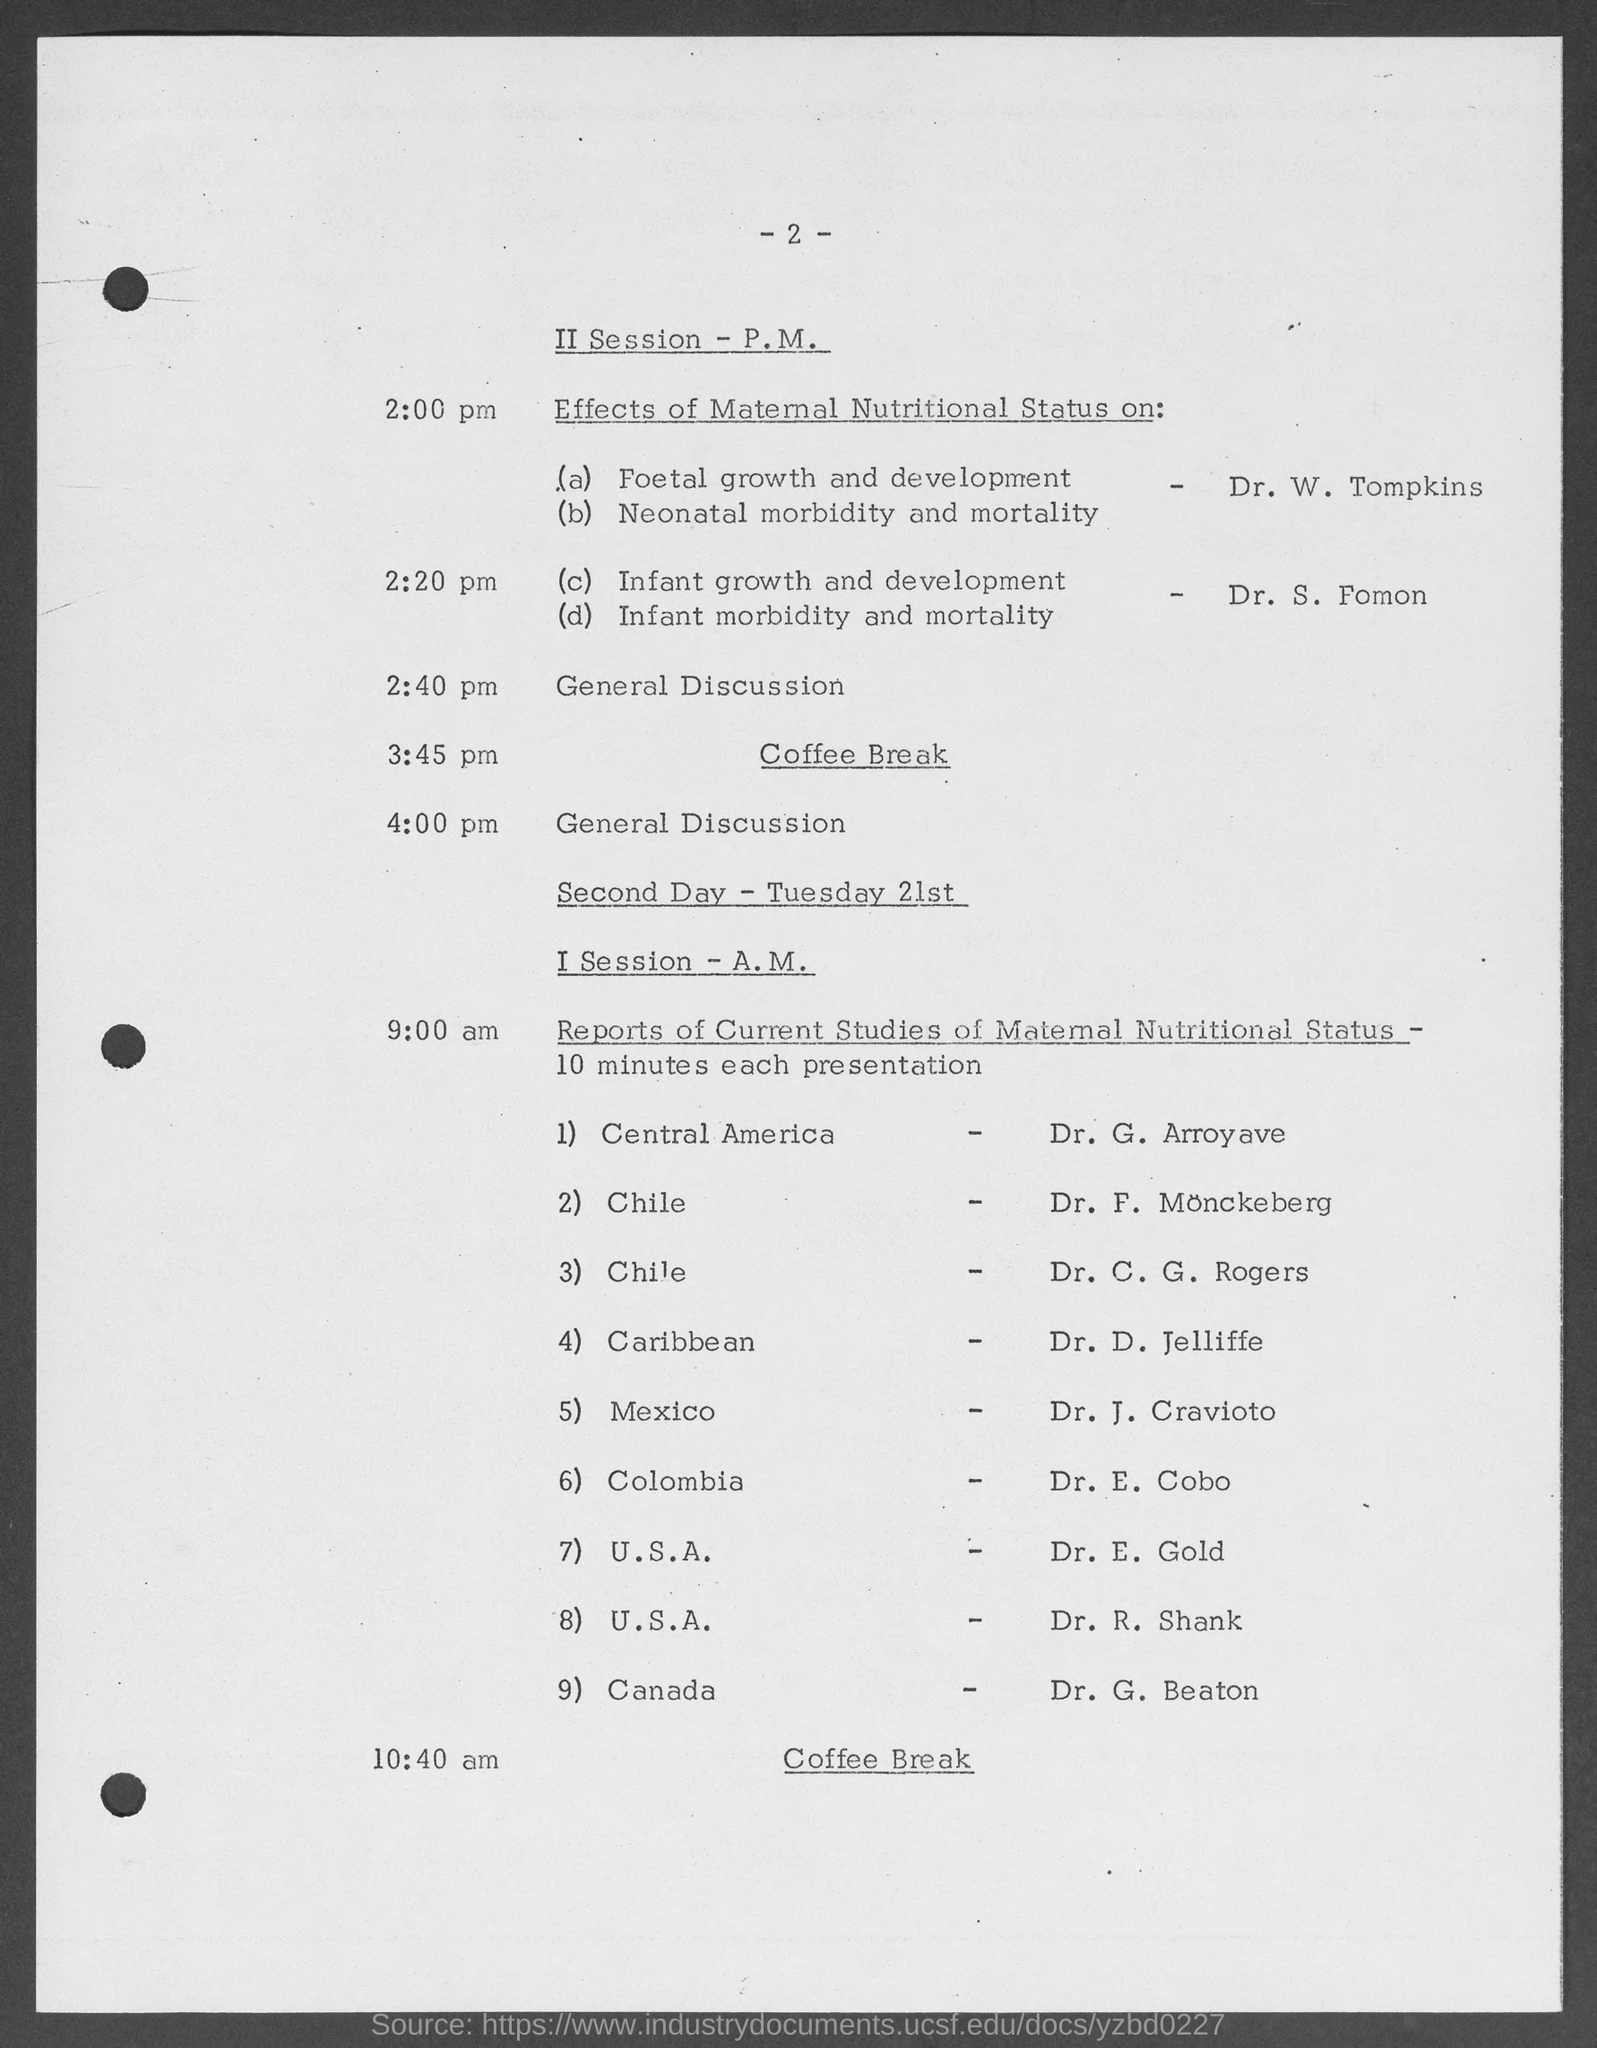Who will be presenting "foetal growth and development"?
Provide a short and direct response. Dr. W. Tompkins. At what time is the coffee break on second day?
Give a very brief answer. 10:40 am. At what time general discussion?
Your answer should be very brief. 2:40 pm. 